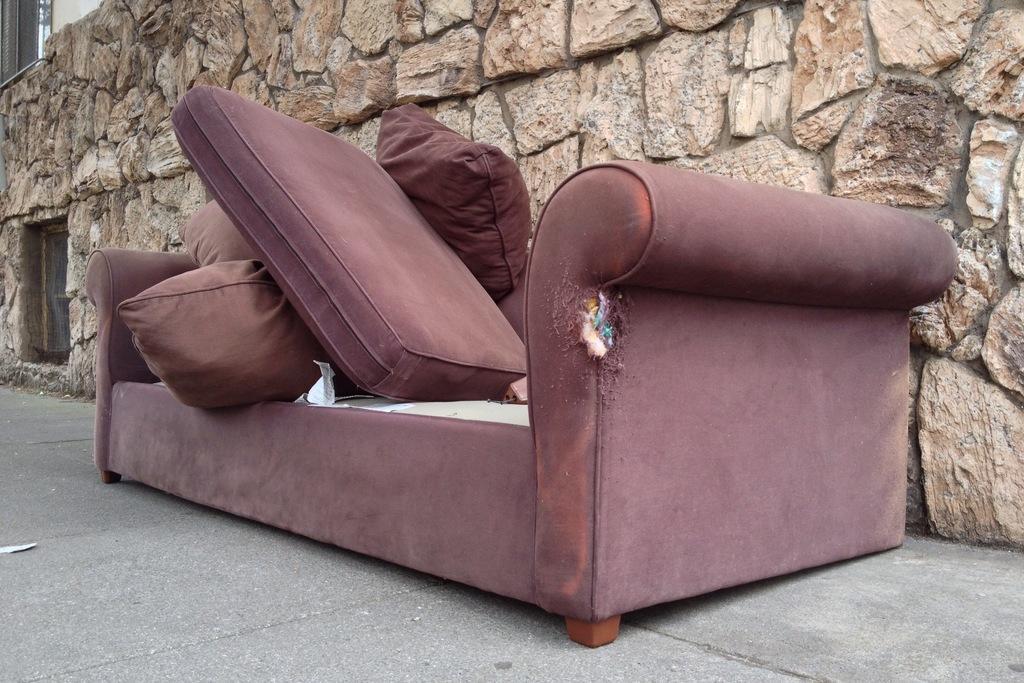Can you describe this image briefly? In this picture we can see an old sofa with cushions kept outside the house on the road. 